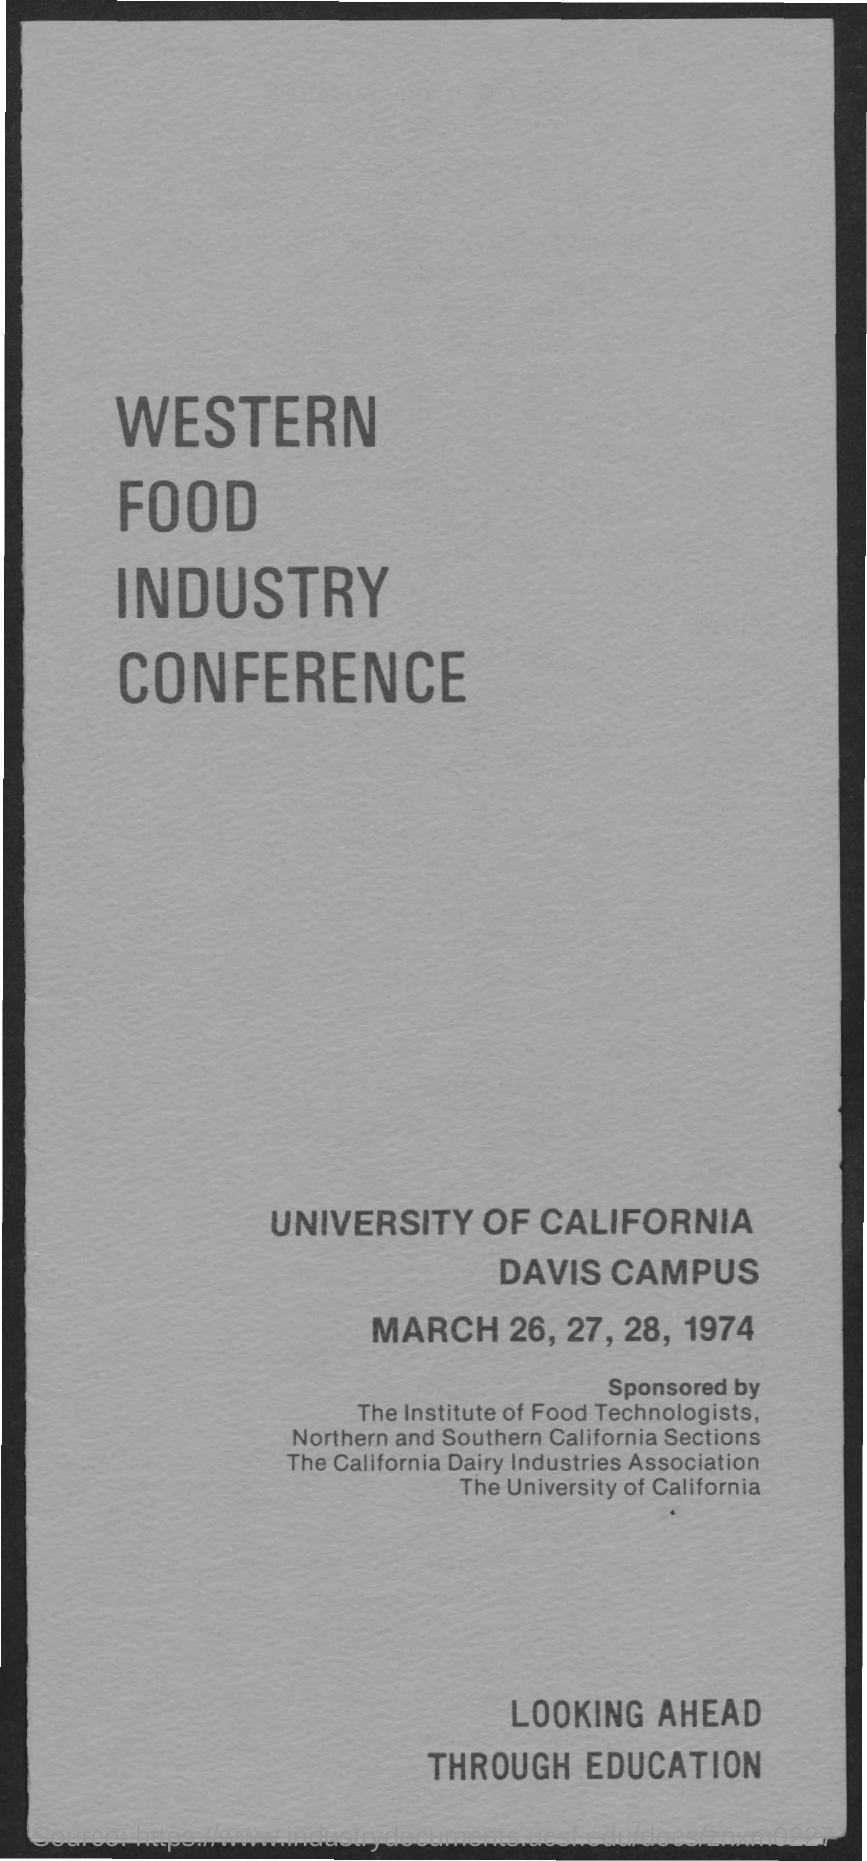List a handful of essential elements in this visual. The western food industry conference was held on March 26, 27, 28, 1974. The Western Food Industry Conference is held at the University of California, Davis Campus. 